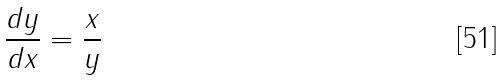Convert formula to latex. <formula><loc_0><loc_0><loc_500><loc_500>\frac { d y } { d x } = \frac { x } { y }</formula> 